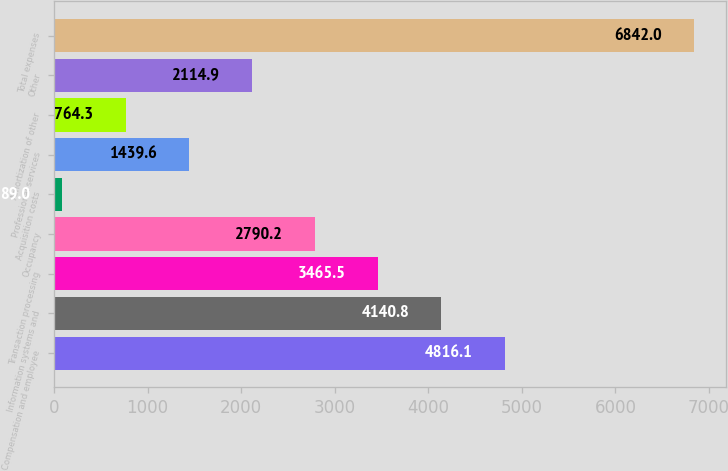Convert chart to OTSL. <chart><loc_0><loc_0><loc_500><loc_500><bar_chart><fcel>Compensation and employee<fcel>Information systems and<fcel>Transaction processing<fcel>Occupancy<fcel>Acquisition costs<fcel>Professional services<fcel>Amortization of other<fcel>Other<fcel>Total expenses<nl><fcel>4816.1<fcel>4140.8<fcel>3465.5<fcel>2790.2<fcel>89<fcel>1439.6<fcel>764.3<fcel>2114.9<fcel>6842<nl></chart> 